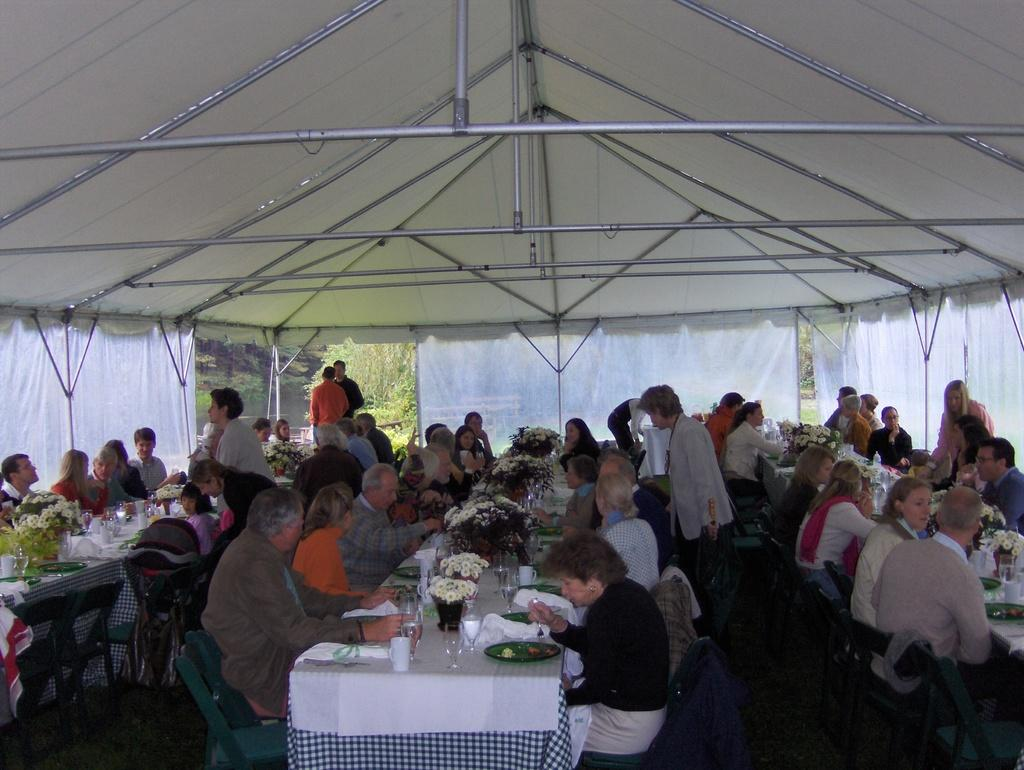What are the people in the image doing? The people in the image are sitting on chairs and eating food. How are the chairs arranged in the image? The chairs are on either side of a table. What is the food served on in the image? The food is served on plates. Where are the plates placed in the image? The plates are placed on tables. What decorative items can be seen on the tables? There are flower pots on the tables. What other items are present on the tables? There are additional plates and cups on the tables. What type of ticket can be seen in the image? There is no ticket present in the image. 